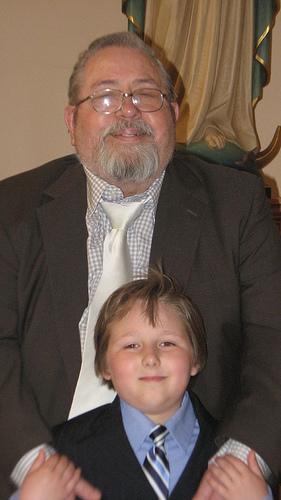Whose tie is more colorful?
Give a very brief answer. Boy. Are they wearing suits?
Be succinct. Yes. Isn't the child pretty clearly the man's grandson?
Write a very short answer. Yes. 